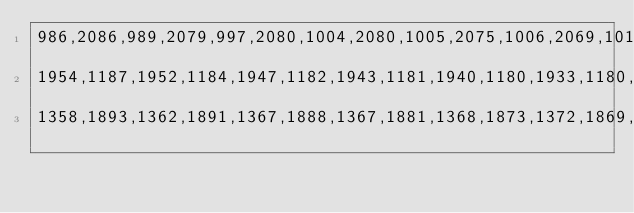<code> <loc_0><loc_0><loc_500><loc_500><_JavaScript_>986,2086,989,2079,997,2080,1004,2080,1005,2075,1006,2069,1012,2070,1015,2071,1021,2076,1026,2081,1035,2074,1044,2067,1053,2069,1061,2070,1064,2070,1073,2070,1082,2070,1089,2068,1092,2065,1096,2060,1096,2051,1098,2048,1111,2047,1123,2046,1125,2055,1126,2063,1131,2060,1148,2058,1149,2048,1149,2037,1147,2027,1144,2017,1147,2011,1148,2009,1152,2008,1157,2007,1164,2007,1166,2002,1165,1995,1164,1981,1179,1977,1182,1974,1185,1974,1188,1974,1189,1972,1194,1971,1197,1968,1200,1965,1198,1960,1194,1956,1192,
1954,1187,1952,1184,1947,1182,1943,1181,1940,1180,1933,1180,1926,1180,1918,1183,1912,1186,1907,1194,1907,1210,1906,1223,1912,1226,1913,1227,1917,1228,1925,1235,1924,1242,1924,1249,1925,1253,1929,1249,1936,1244,1943,1243,1952,1241,1961,1248,1966,1254,1970,1258,1970,1262,1970,1264,1971,1268,1971,1272,1971,1280,1971,1289,1972,1290,1981,1294,1986,1305,1986,1308,1979,1315,1970,1320,1964,1327,1964,1331,1963,1332,1946,1331,1930,1327,1923,1326,1915,1326,1905,1329,1897,1330,1894,1332,1893,1343,1892,1353,1893,
1358,1893,1362,1891,1367,1888,1367,1881,1368,1873,1372,1869,1384,1868,1393,1872,1401,1876,1412,1875,1413,1883,1412,1886,1412,1892,1418,1895,1421,1897,1421,1900,1423,1905,1424,1909,1427,1913,1427,1914,1427,1919,1434,1919,1450,1920,1467,1920,1470,1920,1473,1921,1487,1921,1496,1924,1503,1933,1513,1932,1517,1931,1522,1932,1527,1932,1528,1930,1536,1930,1536,1924,1539,1916,1544,1915,1548,1914,1555,1915,1576,1922,1573,1929,1570,1935,1577,1943,1584,1950,1588,1950,1592,1949,1593,1951,1611,1950,1613,1947,1614,</code> 